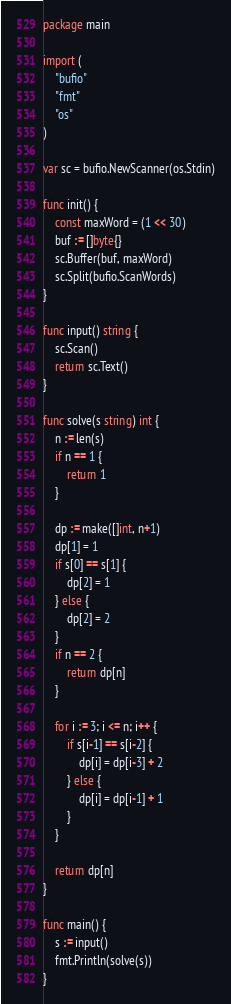Convert code to text. <code><loc_0><loc_0><loc_500><loc_500><_Go_>package main

import (
	"bufio"
	"fmt"
	"os"
)

var sc = bufio.NewScanner(os.Stdin)

func init() {
	const maxWord = (1 << 30)
	buf := []byte{}
	sc.Buffer(buf, maxWord)
	sc.Split(bufio.ScanWords)
}

func input() string {
	sc.Scan()
	return sc.Text()
}

func solve(s string) int {
	n := len(s)
	if n == 1 {
		return 1
	}

	dp := make([]int, n+1)
	dp[1] = 1
	if s[0] == s[1] {
		dp[2] = 1
	} else {
		dp[2] = 2
	}
	if n == 2 {
		return dp[n]
	}

	for i := 3; i <= n; i++ {
		if s[i-1] == s[i-2] {
			dp[i] = dp[i-3] + 2
		} else {
			dp[i] = dp[i-1] + 1
		}
	}

	return dp[n]
}

func main() {
	s := input()
	fmt.Println(solve(s))
}
</code> 